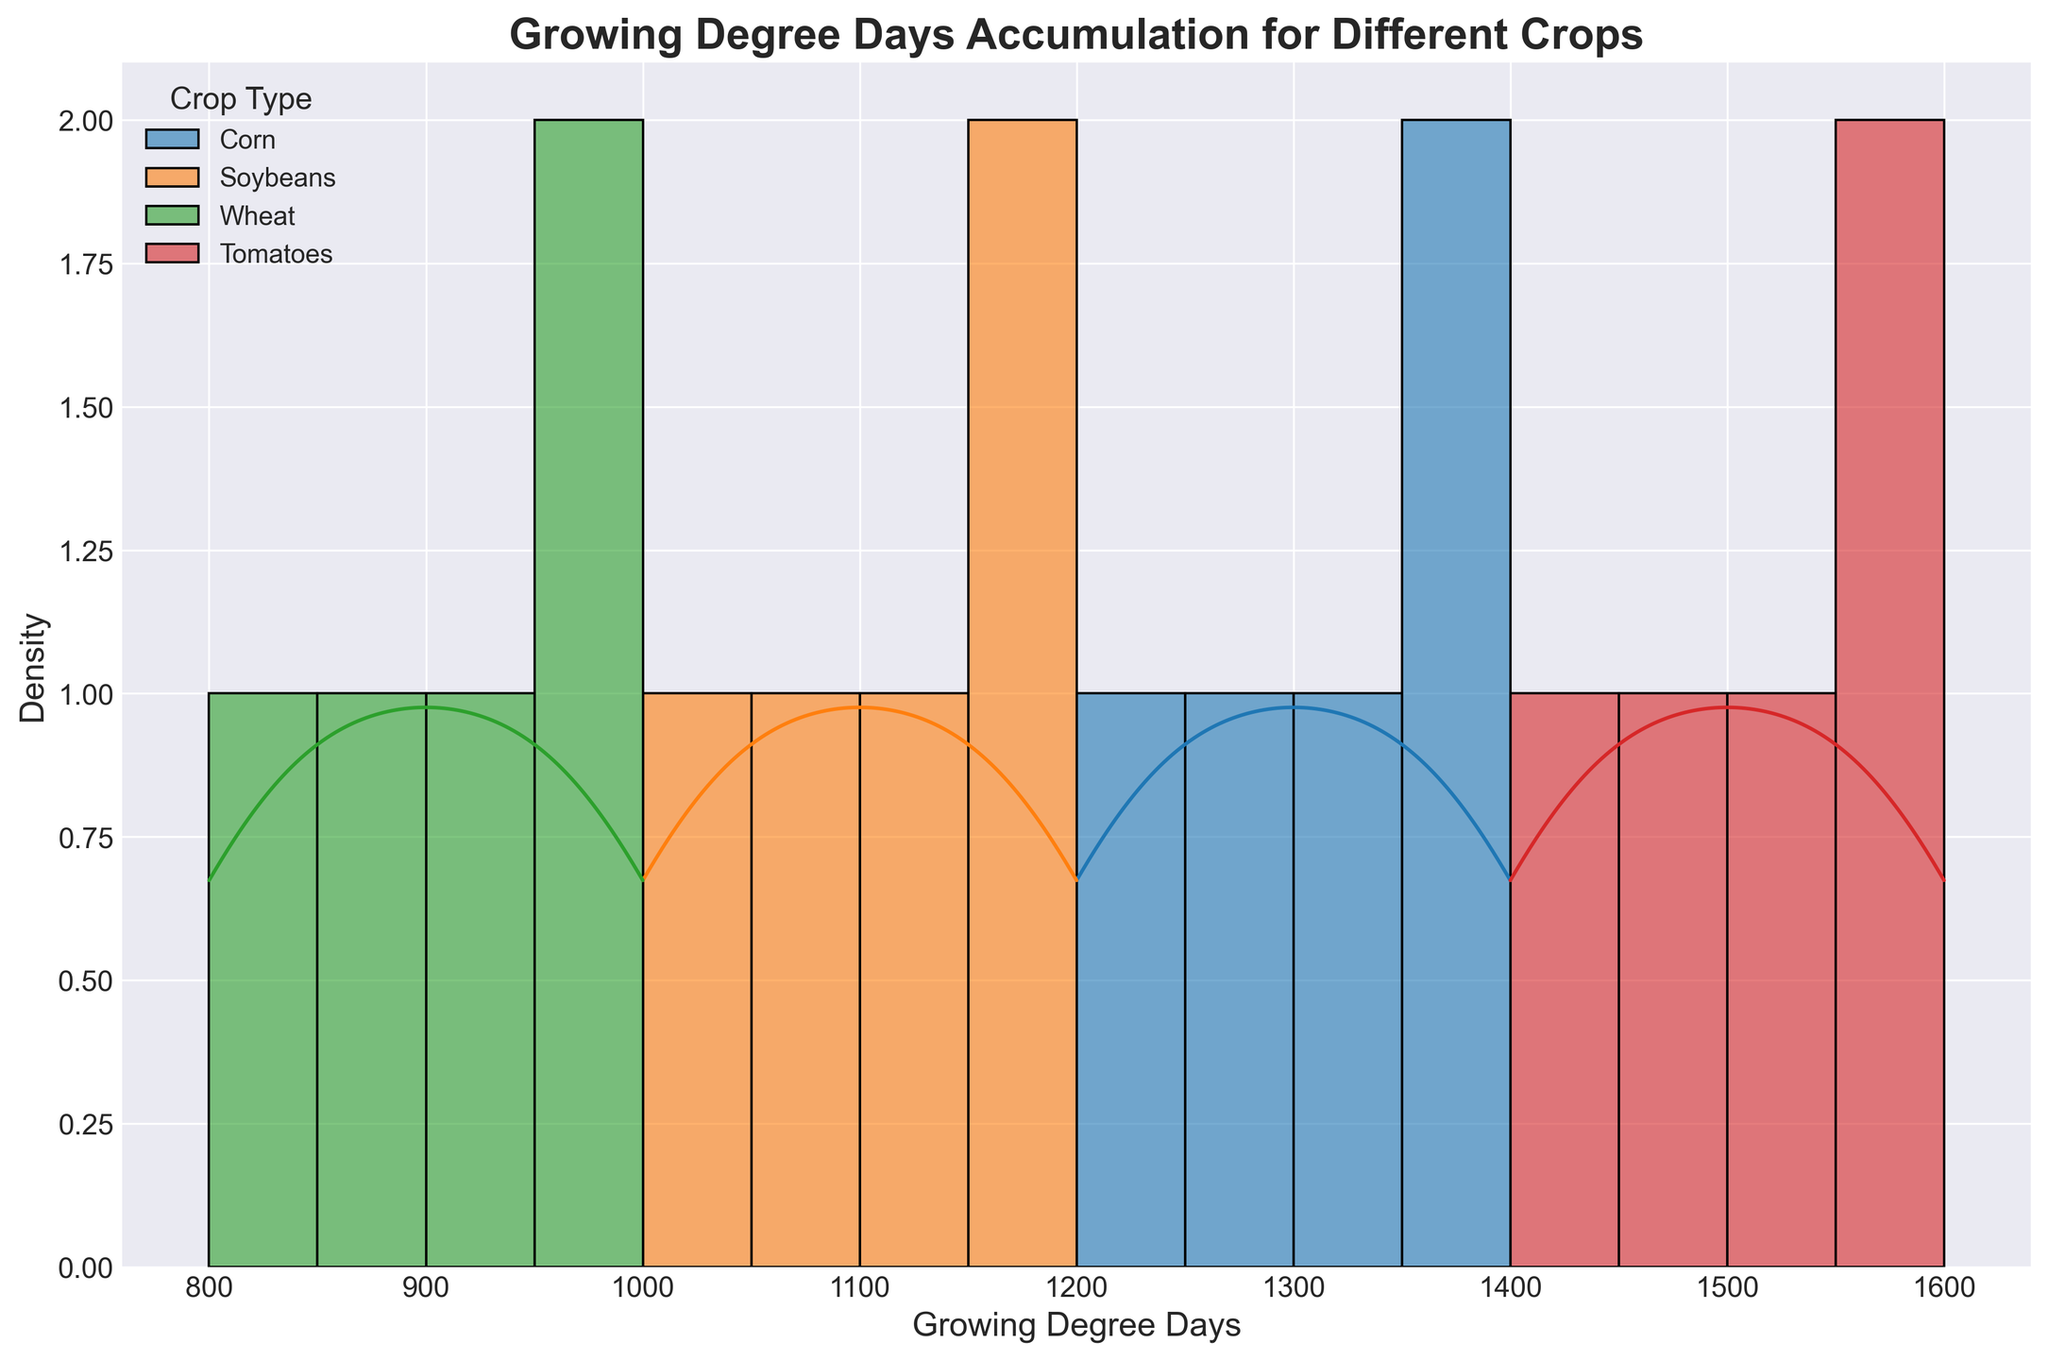How many different crops are shown in the figure? Look at the legend of the figure where each crop type is labeled. Count the number of unique crops listed.
Answer: 4 What is the title of the figure? Refer to the text at the top of the figure which describes the overall subject and purpose of the visualization.
Answer: Growing Degree Days Accumulation for Different Crops Which crop has the highest peak in the density curve? Observe which density curve reaches the highest point on the y-axis.
Answer: Tomatoes What range of Growing Degree Days is most common for Soybeans? Look at the histogram and KDE (density curve) for Soybeans, and identify where the highest bars and peak of the density curve are located.
Answer: 1000 to 1200 How do the Growing Degree Days for Corn compare to Wheat? Observe the KDE (density curve) for both Corn and Wheat and see how their peaks and ranges differ. Corn generally has higher Growing Degree Days than Wheat.
Answer: Corn has higher Growing Degree Days than Wheat What is the minimum Growing Degree Days value recorded for Tomatoes? Look at the histogram bins and KDE (density curve) for Tomatoes to find the starting point on the x-axis.
Answer: 1400 Which crop has the most spread out range of Growing Degree Days? Compare the width of the histograms and KDE (density curves) for each crop. The one that covers the widest range on the x-axis has the most spread.
Answer: Tomatoes Do any crops have overlapping ranges of Growing Degree Days? Examine the histogram bins and KDE (density curves) to see if any crops share a portion of their ranges on the x-axis.
Answer: Yes, Corn and Tomatoes Which crop has the least density at its peak? Look at the KDE (density curve) peaks for each crop and identify which one is lowest on the y-axis.
Answer: Wheat How does the density of Corn’s Growing Degree Days change from 1200 to 1400? Observe the slope and shape of the KDE (density curve) for Corn between 1200 and 1400 on the x-axis.
Answer: The density gradually increases 